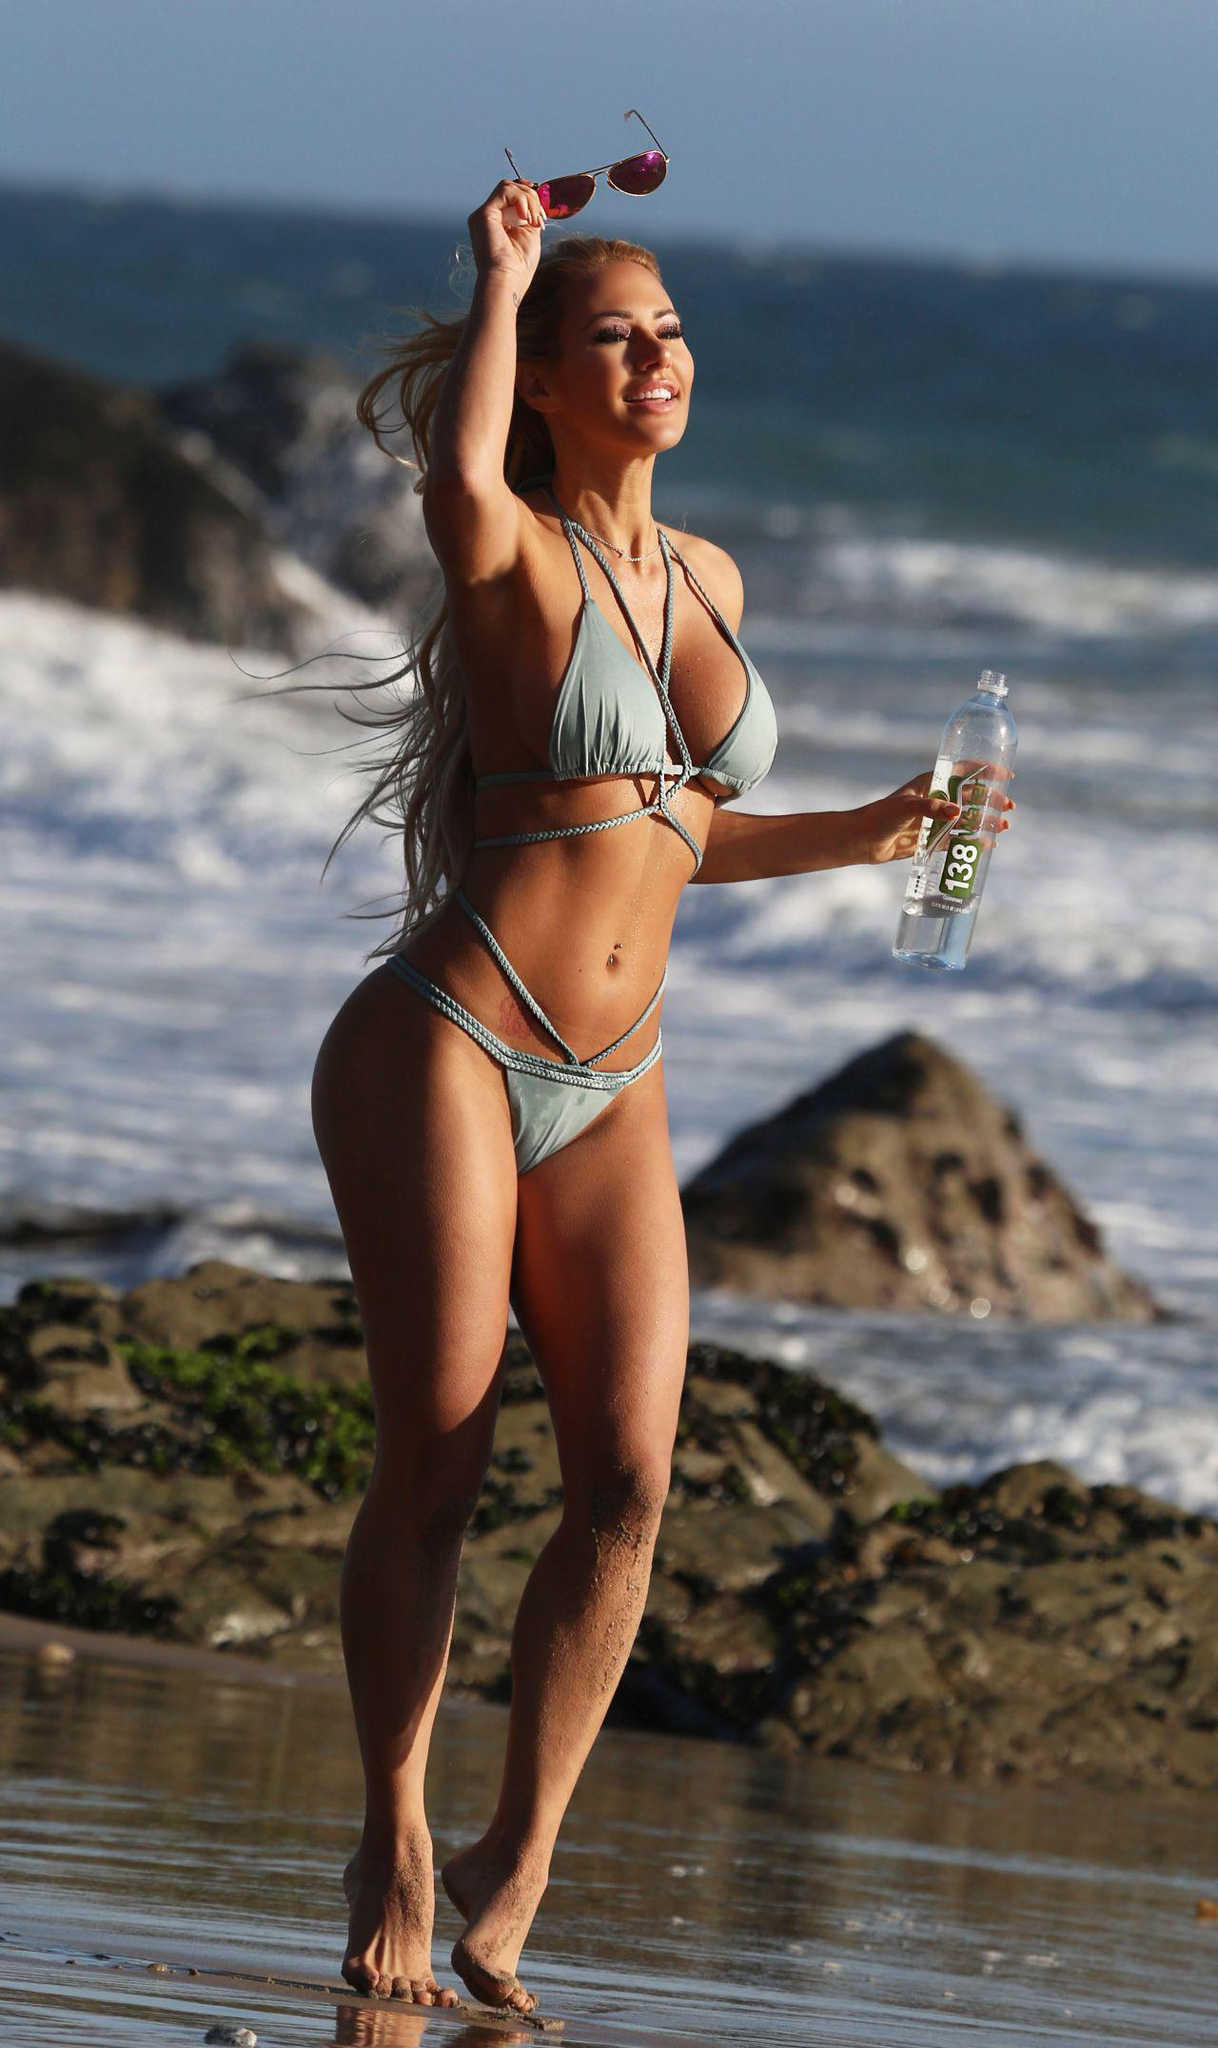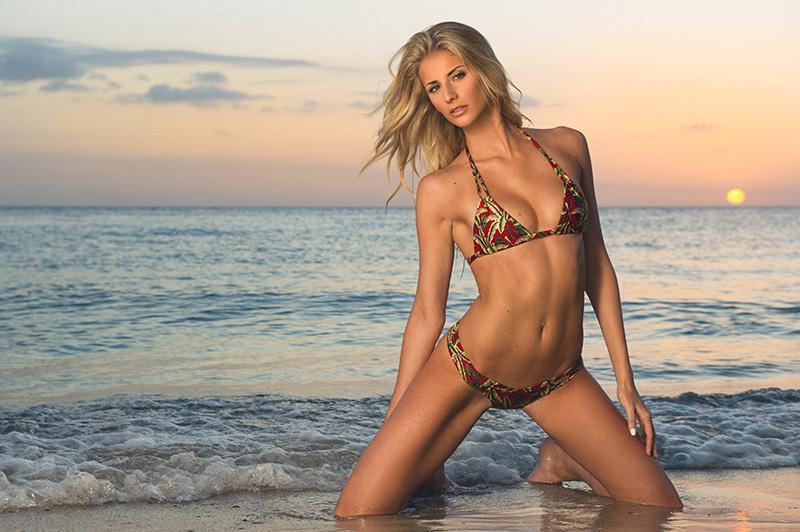The first image is the image on the left, the second image is the image on the right. Considering the images on both sides, is "The right image shows one blonde model in a printed bikini with the arm on the left raised to her head and boulders behind her." valid? Answer yes or no. No. The first image is the image on the left, the second image is the image on the right. For the images shown, is this caption "There are exactly two women." true? Answer yes or no. Yes. 